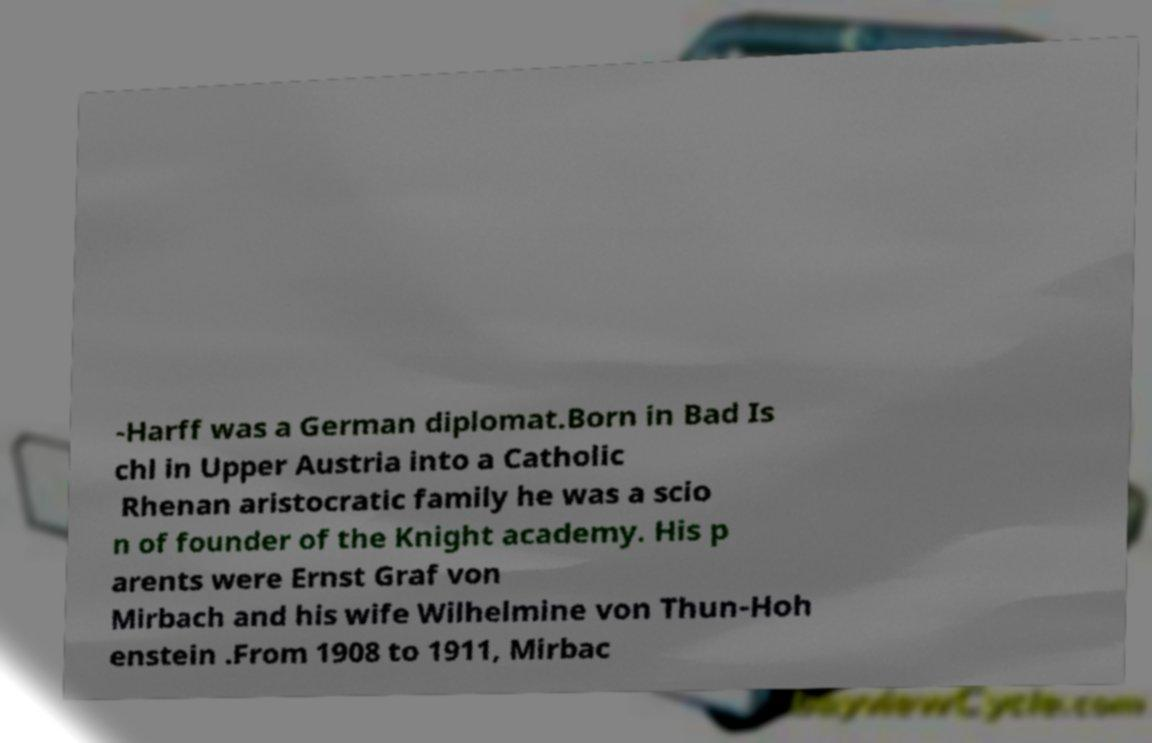Could you assist in decoding the text presented in this image and type it out clearly? -Harff was a German diplomat.Born in Bad Is chl in Upper Austria into a Catholic Rhenan aristocratic family he was a scio n of founder of the Knight academy. His p arents were Ernst Graf von Mirbach and his wife Wilhelmine von Thun-Hoh enstein .From 1908 to 1911, Mirbac 